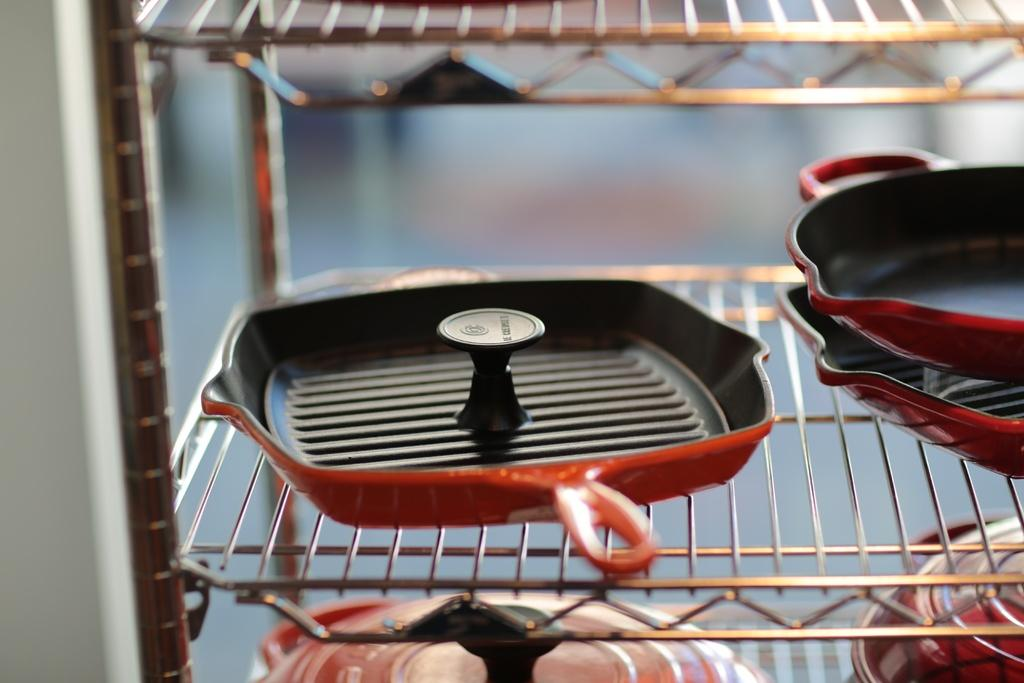What objects are in the foreground of the image? There are vessels and pans in the foreground of the image. How are the vessels and pans arranged in the image? The vessels and pans are in a mesh rack. Can you describe the background of the image? The background of the image is blurred. What type of snake can be seen slithering through the mesh rack in the image? There is no snake present in the image; it features vessels and pans in a mesh rack. 